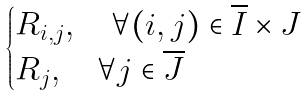Convert formula to latex. <formula><loc_0><loc_0><loc_500><loc_500>\begin{cases} R _ { i , j } , \quad \forall ( i , j ) \in \overline { I } \times J \\ R _ { j } , \quad \forall j \in \overline { J } \end{cases}</formula> 